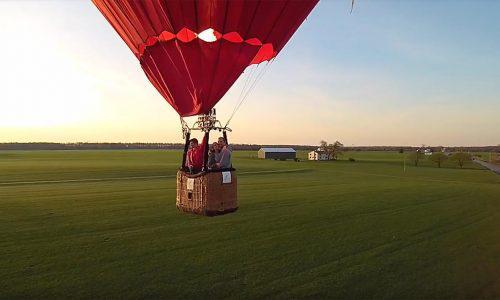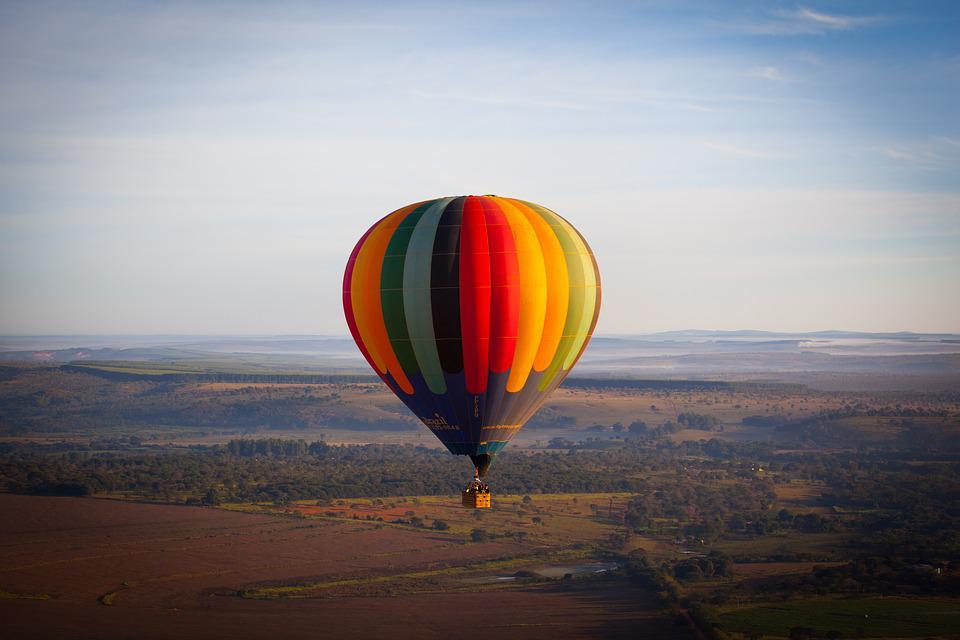The first image is the image on the left, the second image is the image on the right. Evaluate the accuracy of this statement regarding the images: "An image shows a solid-red balloon floating above a green field.". Is it true? Answer yes or no. Yes. 